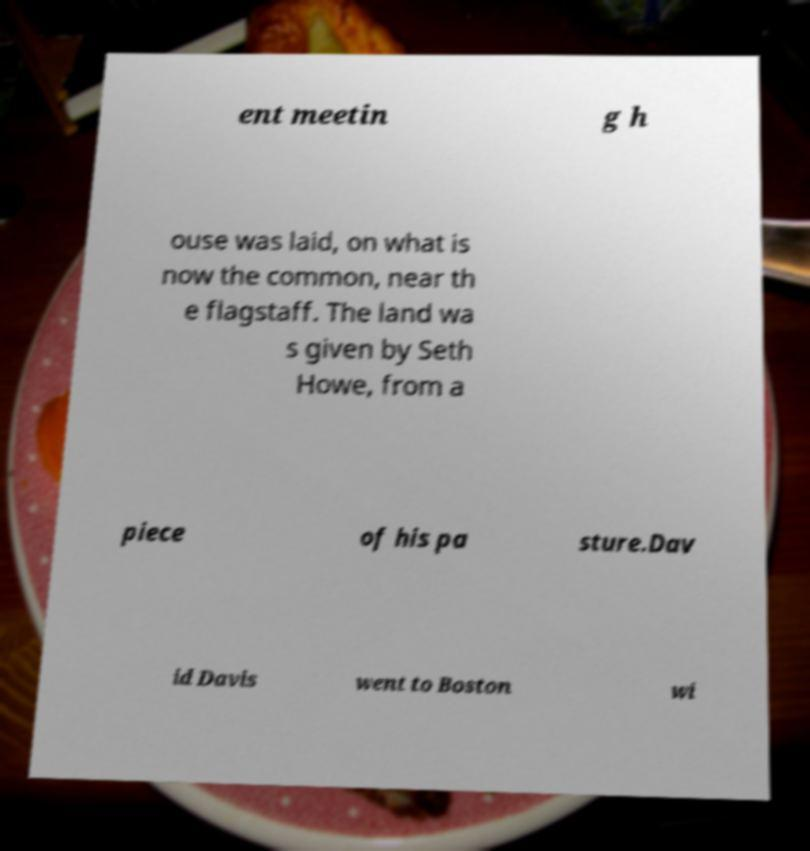Can you read and provide the text displayed in the image?This photo seems to have some interesting text. Can you extract and type it out for me? ent meetin g h ouse was laid, on what is now the common, near th e flagstaff. The land wa s given by Seth Howe, from a piece of his pa sture.Dav id Davis went to Boston wi 